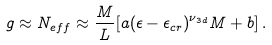Convert formula to latex. <formula><loc_0><loc_0><loc_500><loc_500>g \approx N _ { e f f } \approx \frac { M } { L } [ a ( \epsilon - \epsilon _ { c r } ) ^ { \nu _ { 3 d } } M + b ] \, .</formula> 